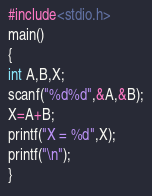<code> <loc_0><loc_0><loc_500><loc_500><_C_>#include<stdio.h>
main()
{
int A,B,X;
scanf("%d%d",&A,&B);
X=A+B;
printf("X = %d",X);
printf("\n");
}
</code> 